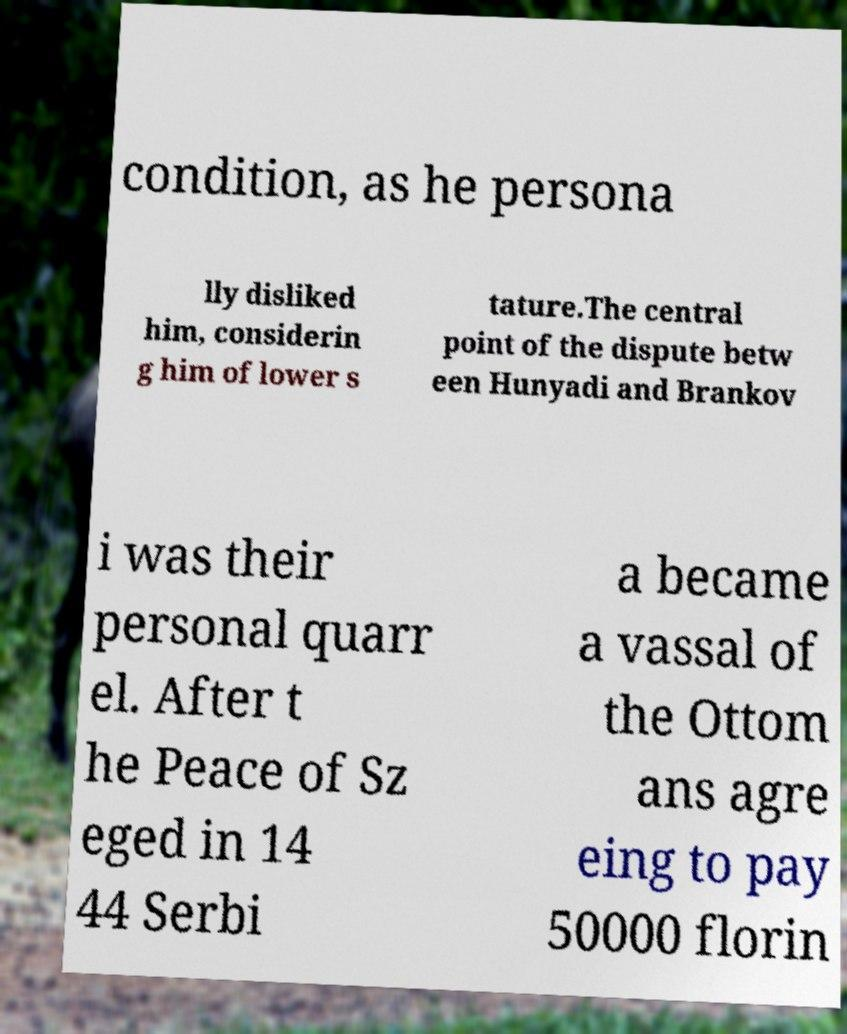What messages or text are displayed in this image? I need them in a readable, typed format. condition, as he persona lly disliked him, considerin g him of lower s tature.The central point of the dispute betw een Hunyadi and Brankov i was their personal quarr el. After t he Peace of Sz eged in 14 44 Serbi a became a vassal of the Ottom ans agre eing to pay 50000 florin 